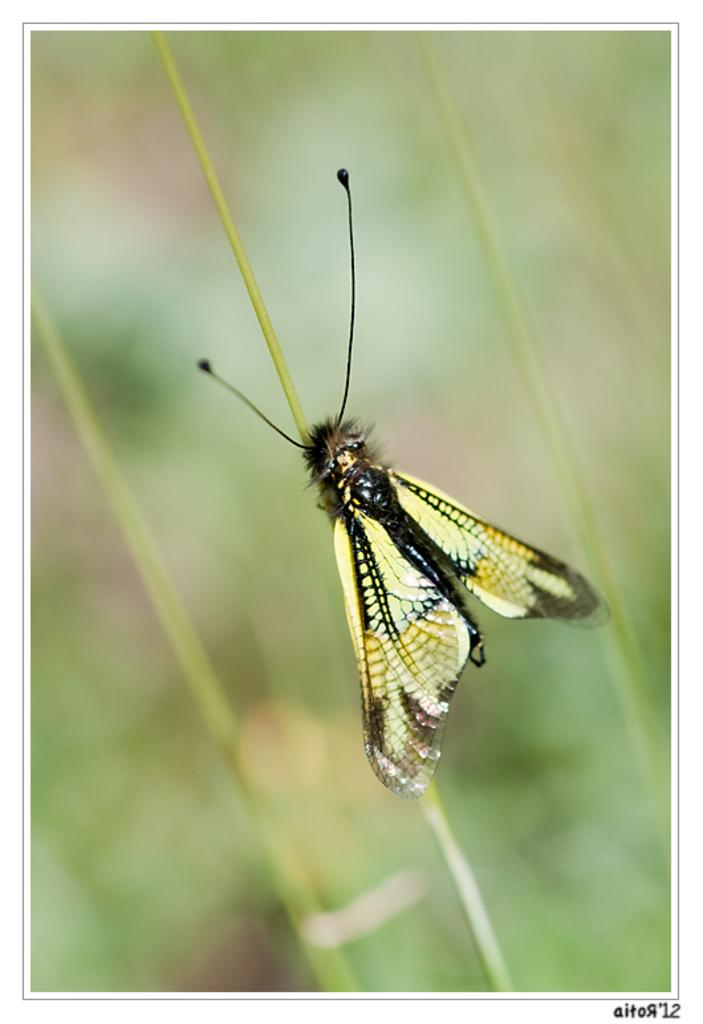What is the main subject of the image? There is a butterfly in the image. What is the butterfly resting on? The butterfly is laying on grass. What color is the background of the image? The background of the image is blue. What type of bike can be seen in the image? There is no bike present in the image; it features a butterfly laying on grass with a blue background. 